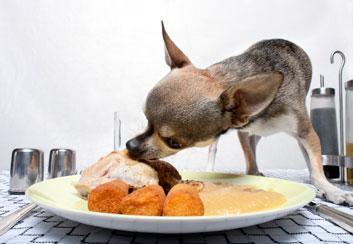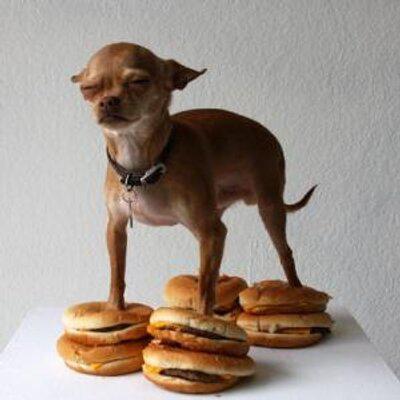The first image is the image on the left, the second image is the image on the right. Evaluate the accuracy of this statement regarding the images: "Two dogs are shown standing near food.". Is it true? Answer yes or no. Yes. The first image is the image on the left, the second image is the image on the right. Evaluate the accuracy of this statement regarding the images: "At least one image shows a single dog standing behind a white plate with multiple food items on it.". Is it true? Answer yes or no. Yes. 